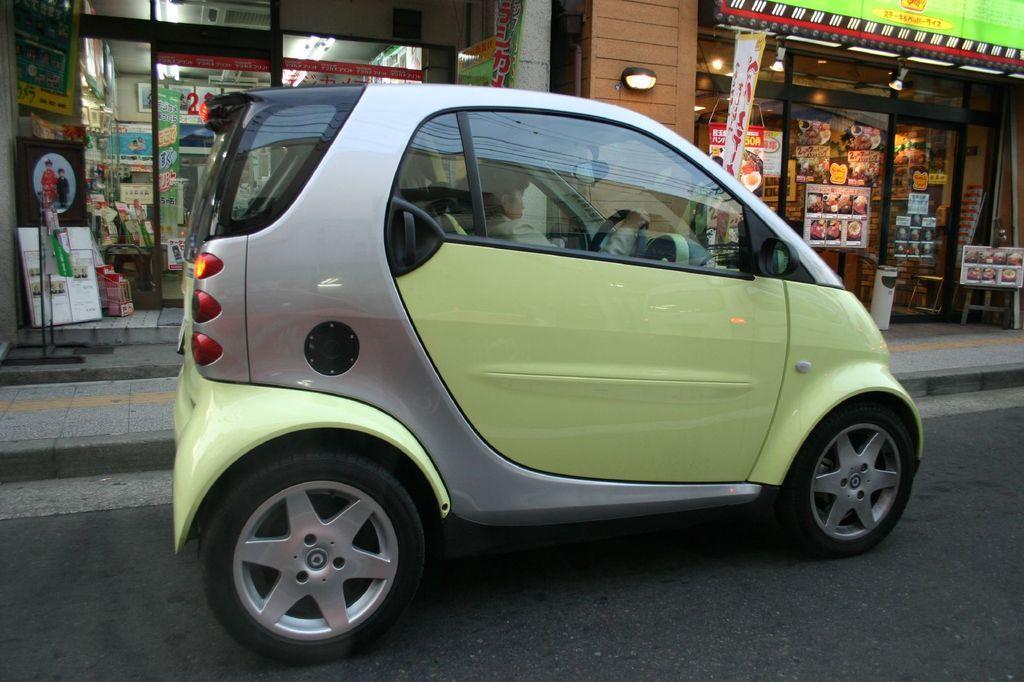Could you give a brief overview of what you see in this image? In the picture we can see a road on it, we can see a car near the path which is light green in color and some part of gray in color and behind the car we can see some shops with glass walls and door and into the glass walls we can see some posters and some stickers are passed to it. 